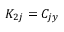Convert formula to latex. <formula><loc_0><loc_0><loc_500><loc_500>K _ { 2 j } = C _ { j y }</formula> 